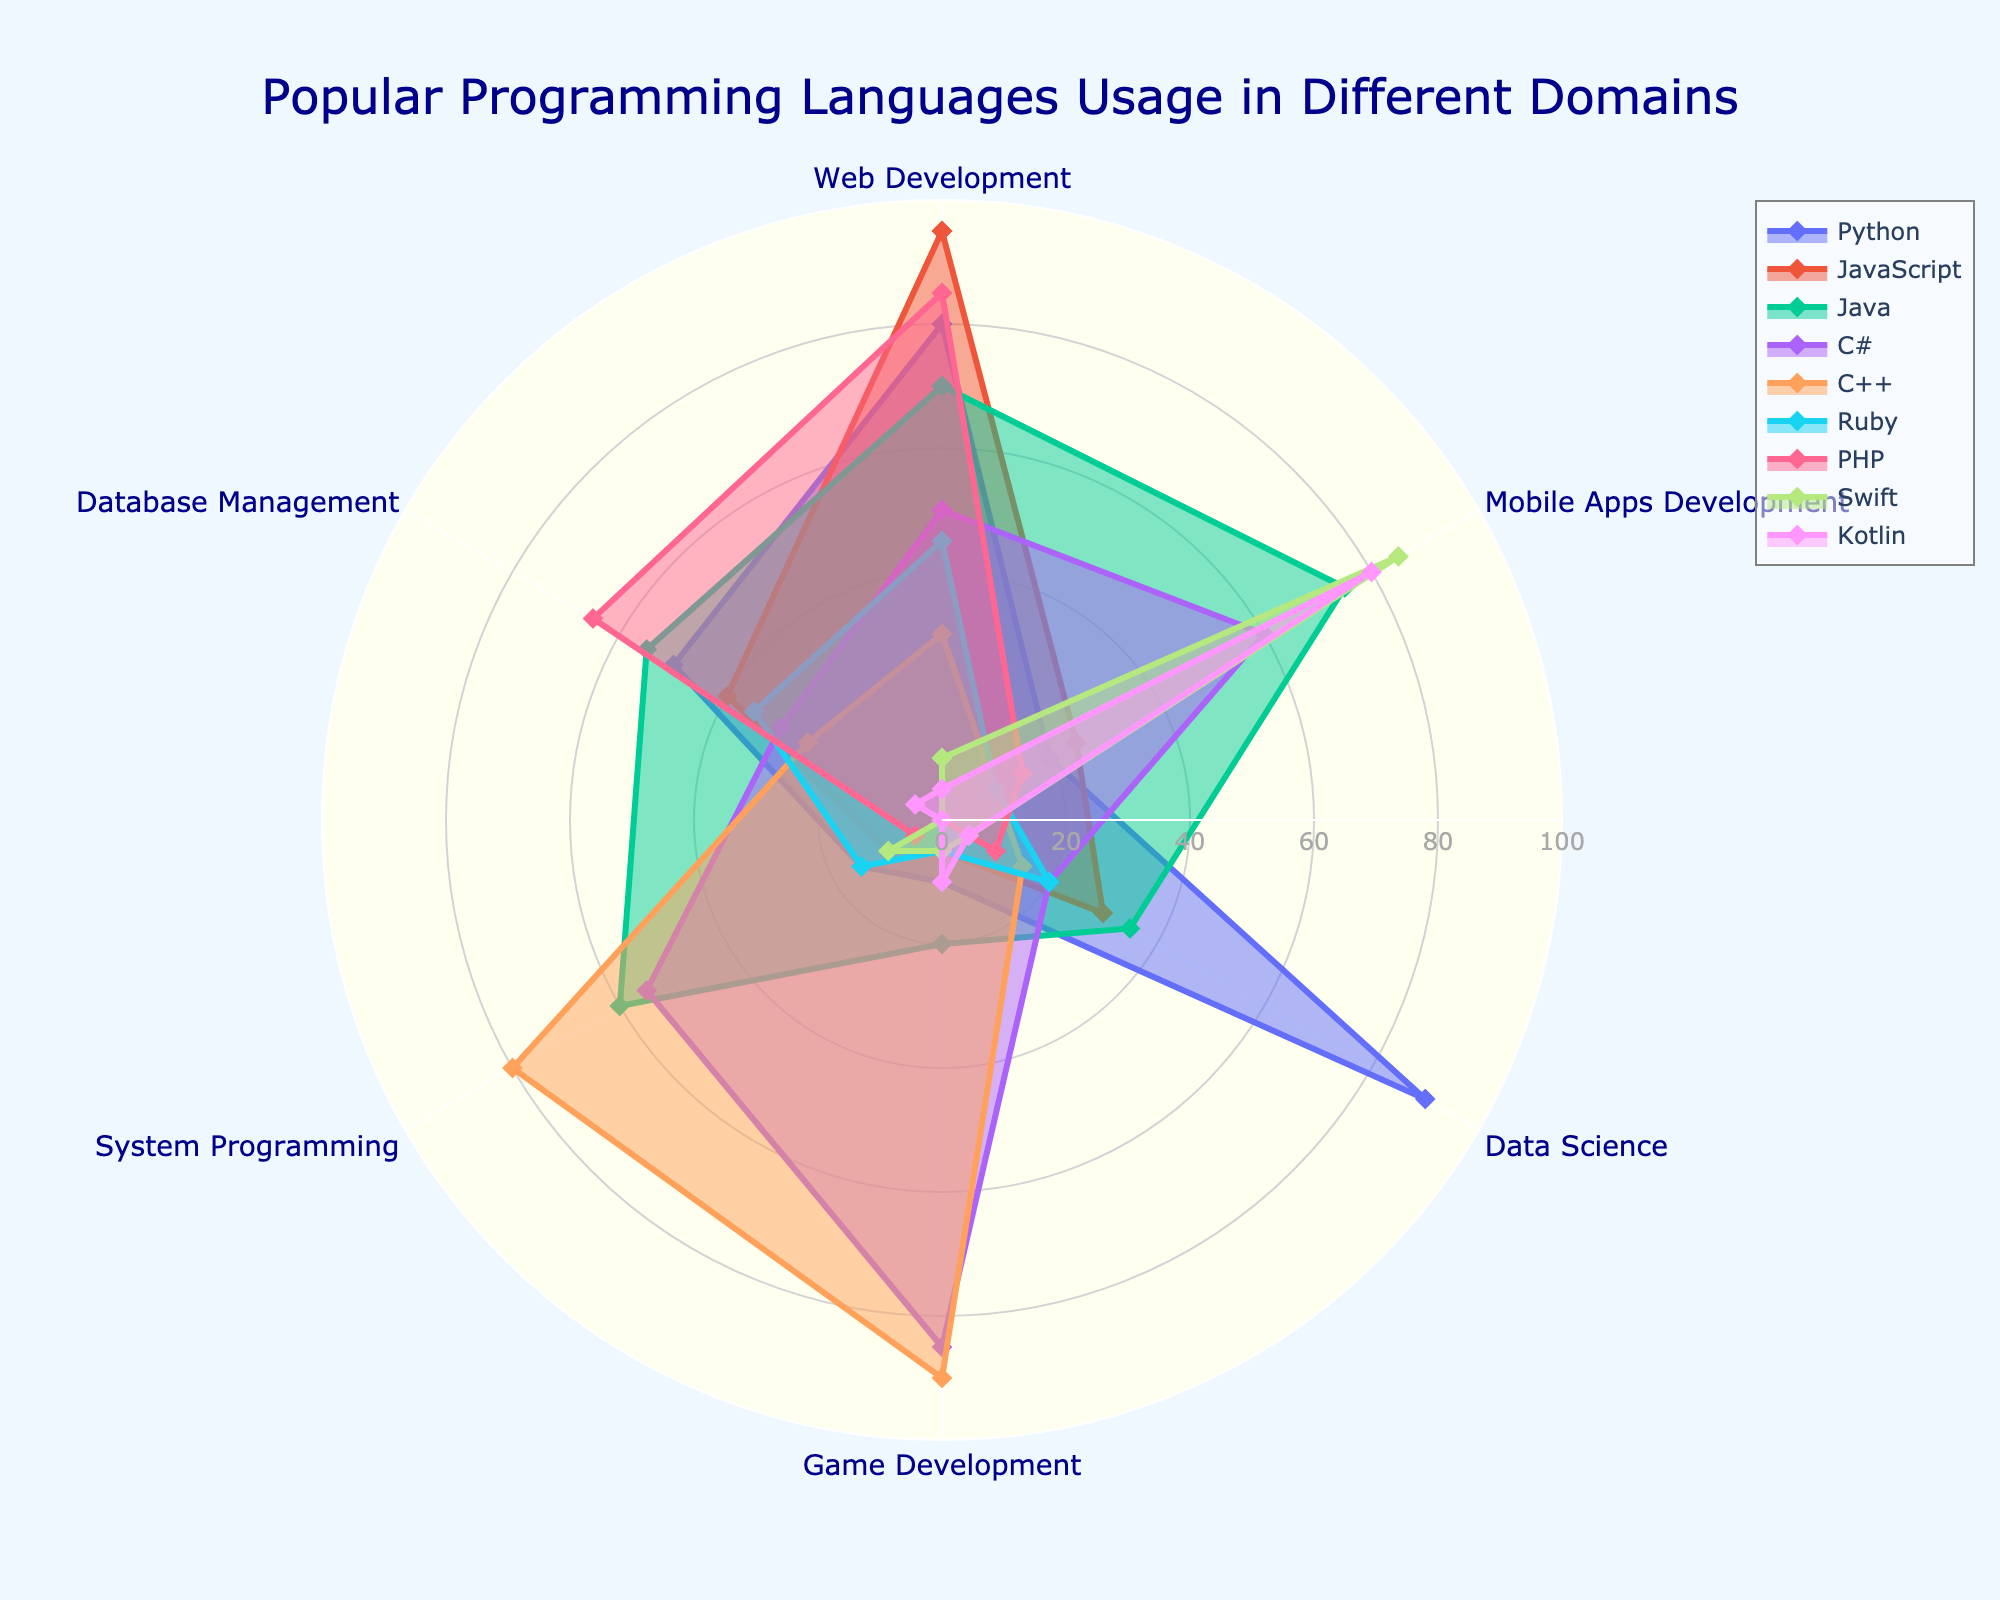What is the title of the chart? The title of the chart is usually displayed prominently at the top and provides a summary of what the chart is about. In this case, it reads "Popular Programming Languages Usage in Different Domains."
Answer: Popular Programming Languages Usage in Different Domains Which programming language has the highest usage percentage in Web Development? To find this, look at the Web Development axis. The programming language with the highest value on this axis is JavaScript with a value of 95.
Answer: JavaScript How many categories are used to describe the programming languages? Count the number of axes originating from the center of the polar chart. There are six categories: Web Development, Mobile Apps Development, Data Science, Game Development, System Programming, and Database Management.
Answer: Six Which programming language is least used in System Programming, and what is its usage percentage? Move along the System Programming axis to determine the programming language with the lowest value. Swift and Kotlin both have the lowest value of 0 in System Programming.
Answer: Swift and Kotlin, 0 Compare the games development usage between C# and C++. Which is higher? Trace the Game Development axis for both C# and C++. C++ has a higher value of 90 compared to C# with 85.
Answer: C++ Sum up the usage percentages of Python in Web Development and Data Science. Look at the Web Development usage for Python, which is 80, and the Data Science usage, which is 90. Adding these gives 80 + 90 = 170.
Answer: 170 Which programming language shows a relatively even spread across all categories? Examine each programming language's plot. Python, for instance, has values of 80, 20, 90, 10, 15, and 50, showing more variance. Java, however, has values more balanced across categories, with figures like 70, 75, 35, 20, 60, and 55.
Answer: Java What is the average usage of PHP across all domains? Calculate the sum of PHP's values across all 6 domains: 85, 15, 10, 0, 5, 65; then divide by 6, which equals (85+15+10+0+5+65)/6 = 180/6 = 30.
Answer: 30 Which programming language other than Python has a high Data Science usage value? Scan the Data Science axis for values other than Python, whose value is 90. The next highest is Java, with a value of 35.
Answer: Java What are the Web Development usage percentages for C# and Ruby, and which is higher? Check the Web Development values for C# (50) and Ruby (45). C# has a higher value.
Answer: C# is higher with 50 